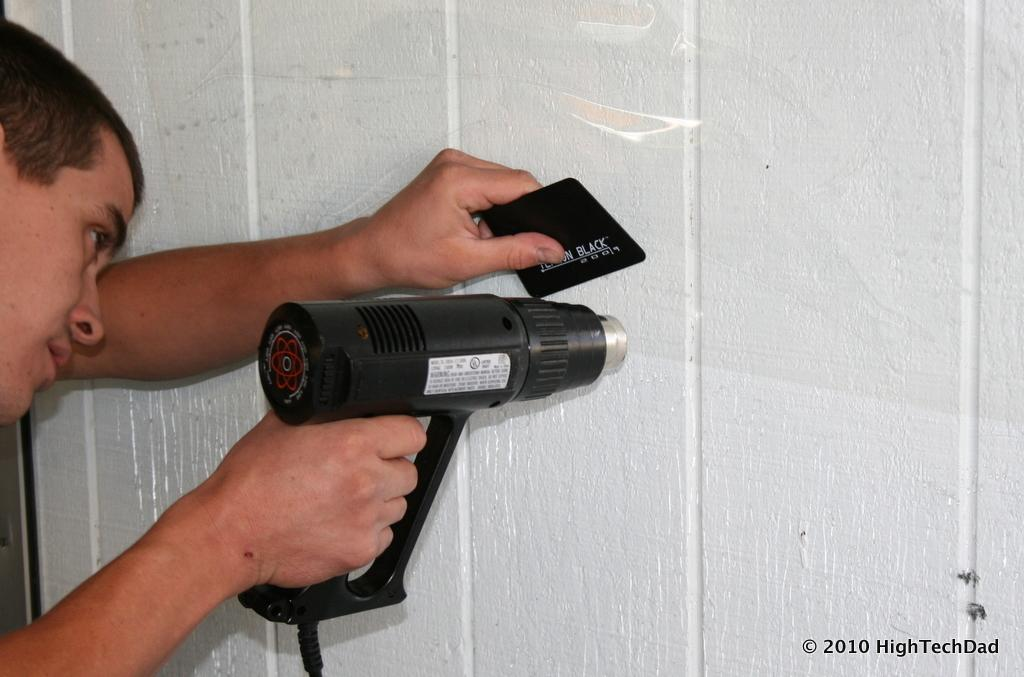Who is the person in the image? There is a man in the image. What is the man doing in the image? The man is using a drill machine. Can you describe the drill machine? The drill machine is black in color. What is the man doing with the drill machine? The man is drilling a hole in the wall. What type of care does the man need after using the drill machine? There is no indication in the image that the man needs any care after using the drill machine. 